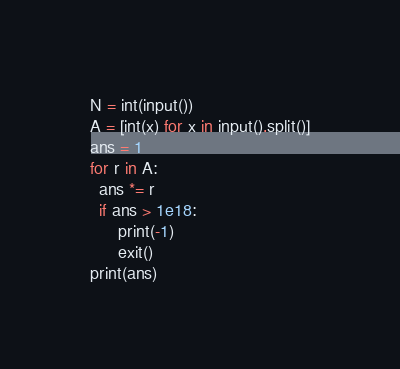Convert code to text. <code><loc_0><loc_0><loc_500><loc_500><_Python_>N = int(input())
A = [int(x) for x in input().split()]
ans = 1
for r in A:
  ans *= r
  if ans > 1e18:
      print(-1)
      exit()
print(ans)</code> 